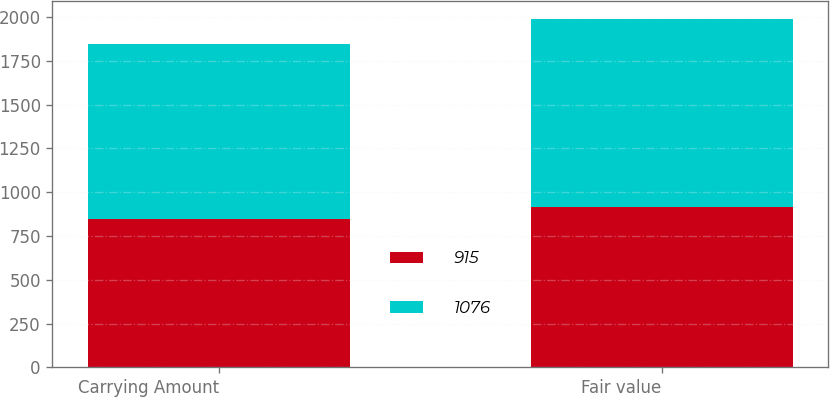Convert chart. <chart><loc_0><loc_0><loc_500><loc_500><stacked_bar_chart><ecel><fcel>Carrying Amount<fcel>Fair value<nl><fcel>915<fcel>844<fcel>915<nl><fcel>1076<fcel>1003<fcel>1076<nl></chart> 